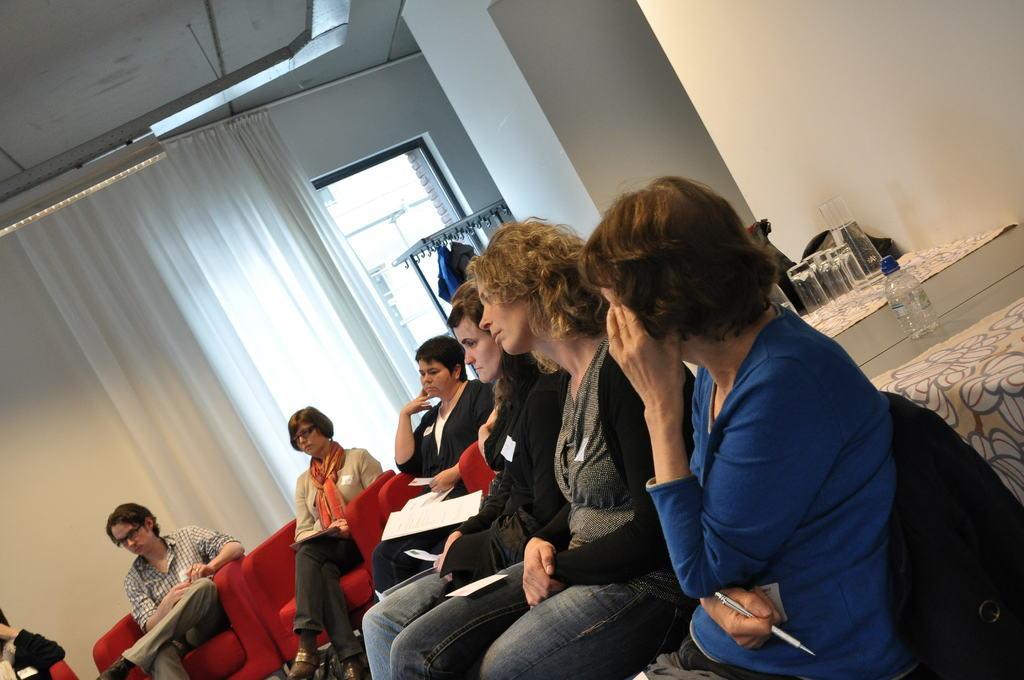Could you give a brief overview of what you see in this image? In this picture we can see a few people sitting on the chair. There are a few papers, glasses, bottles and other things are visible on the right side. We can see a curtain, pillar and other objects visible in the background. 